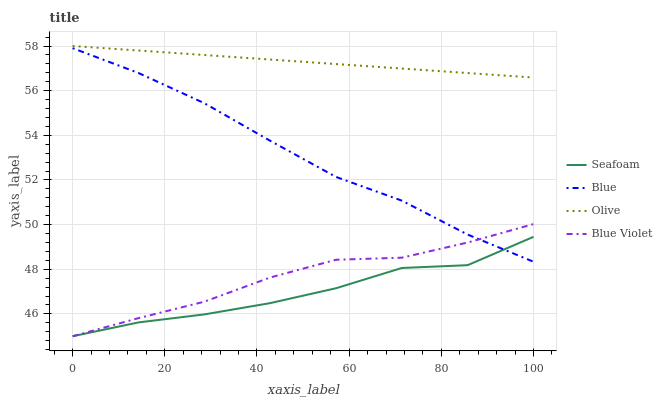Does Seafoam have the minimum area under the curve?
Answer yes or no. Yes. Does Olive have the maximum area under the curve?
Answer yes or no. Yes. Does Olive have the minimum area under the curve?
Answer yes or no. No. Does Seafoam have the maximum area under the curve?
Answer yes or no. No. Is Olive the smoothest?
Answer yes or no. Yes. Is Seafoam the roughest?
Answer yes or no. Yes. Is Seafoam the smoothest?
Answer yes or no. No. Is Olive the roughest?
Answer yes or no. No. Does Olive have the lowest value?
Answer yes or no. No. Does Olive have the highest value?
Answer yes or no. Yes. Does Seafoam have the highest value?
Answer yes or no. No. Is Seafoam less than Olive?
Answer yes or no. Yes. Is Olive greater than Blue Violet?
Answer yes or no. Yes. Does Seafoam intersect Olive?
Answer yes or no. No. 